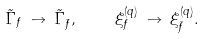<formula> <loc_0><loc_0><loc_500><loc_500>\tilde { \Gamma } _ { f } \, \to \, \tilde { \Gamma } _ { \bar { f } } , \quad \, \xi _ { f } ^ { ( q ) } \, \to \, \xi _ { \bar { f } } ^ { ( q ) } .</formula> 